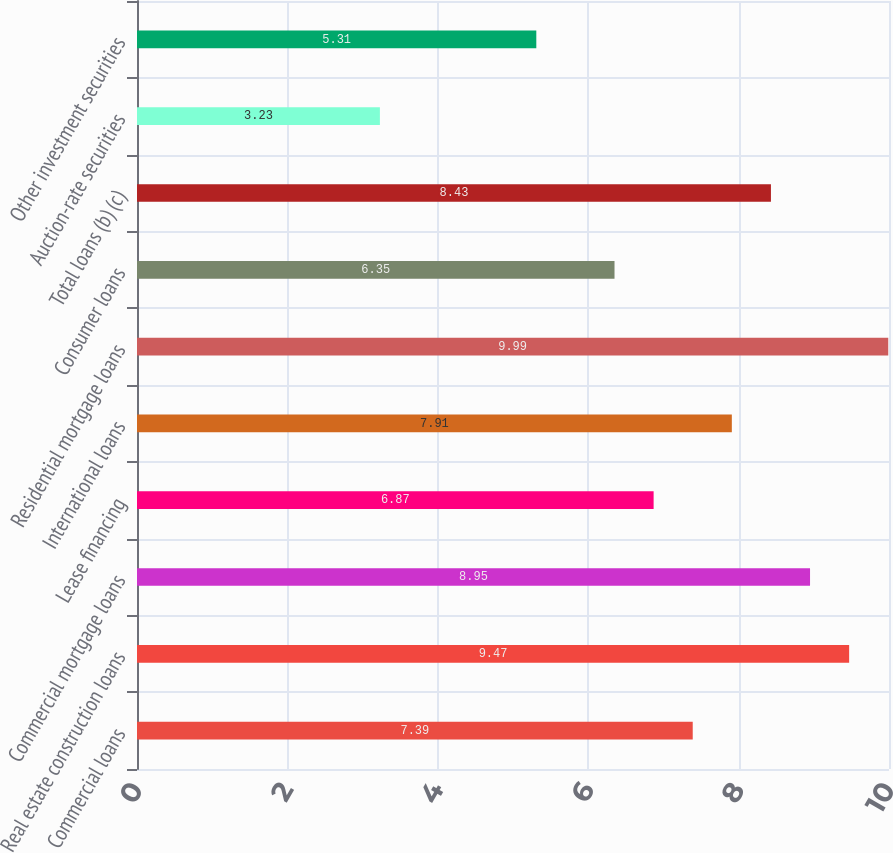Convert chart. <chart><loc_0><loc_0><loc_500><loc_500><bar_chart><fcel>Commercial loans<fcel>Real estate construction loans<fcel>Commercial mortgage loans<fcel>Lease financing<fcel>International loans<fcel>Residential mortgage loans<fcel>Consumer loans<fcel>Total loans (b) (c)<fcel>Auction-rate securities<fcel>Other investment securities<nl><fcel>7.39<fcel>9.47<fcel>8.95<fcel>6.87<fcel>7.91<fcel>9.99<fcel>6.35<fcel>8.43<fcel>3.23<fcel>5.31<nl></chart> 